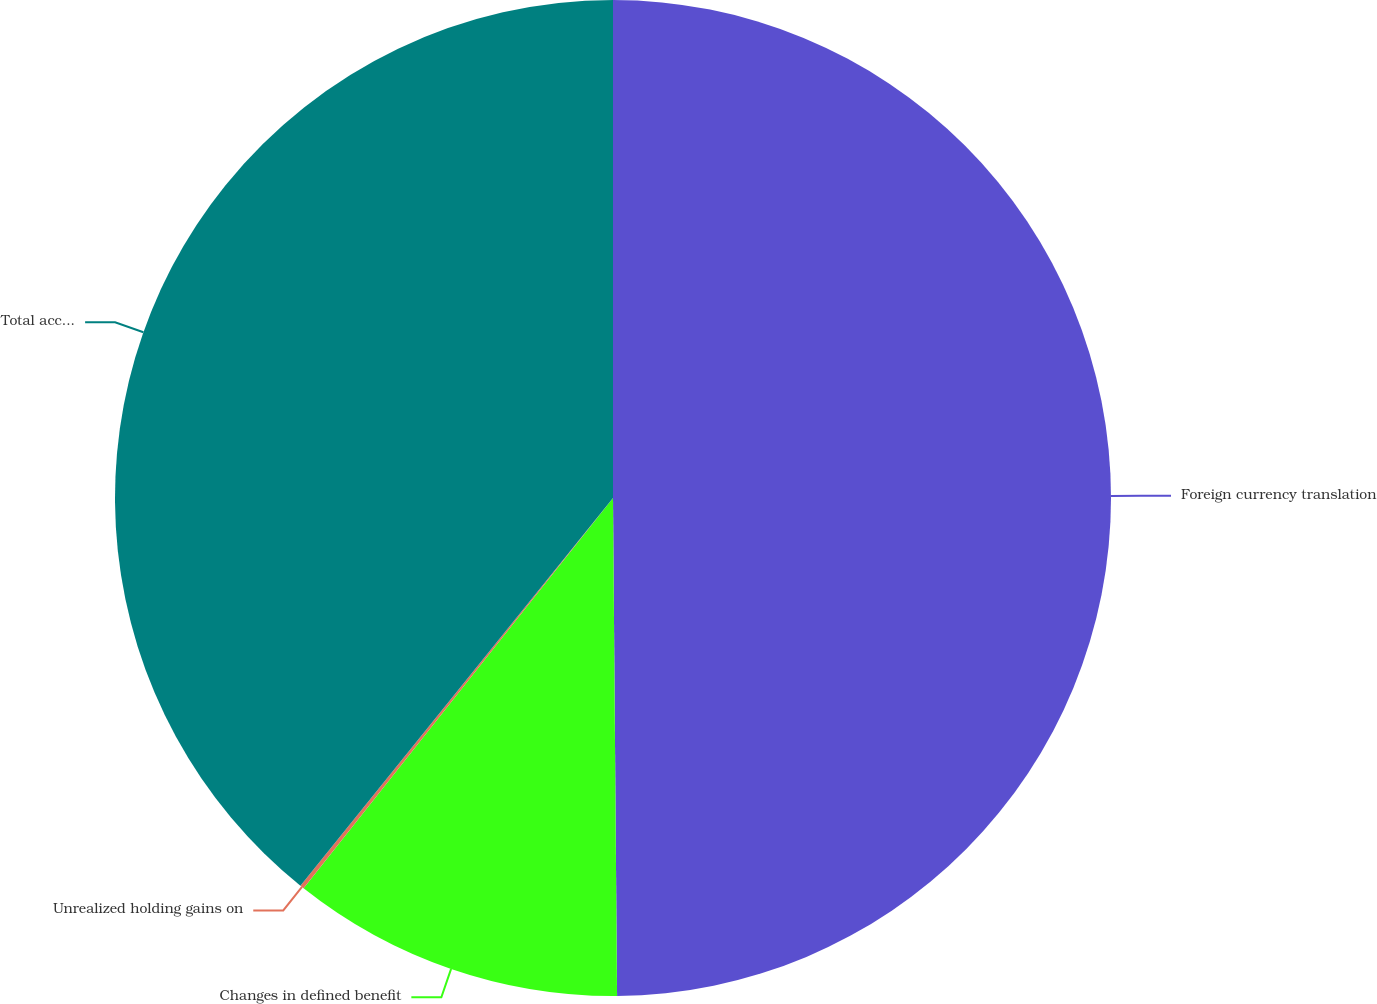Convert chart. <chart><loc_0><loc_0><loc_500><loc_500><pie_chart><fcel>Foreign currency translation<fcel>Changes in defined benefit<fcel>Unrealized holding gains on<fcel>Total accumulated other<nl><fcel>49.87%<fcel>10.8%<fcel>0.13%<fcel>39.2%<nl></chart> 